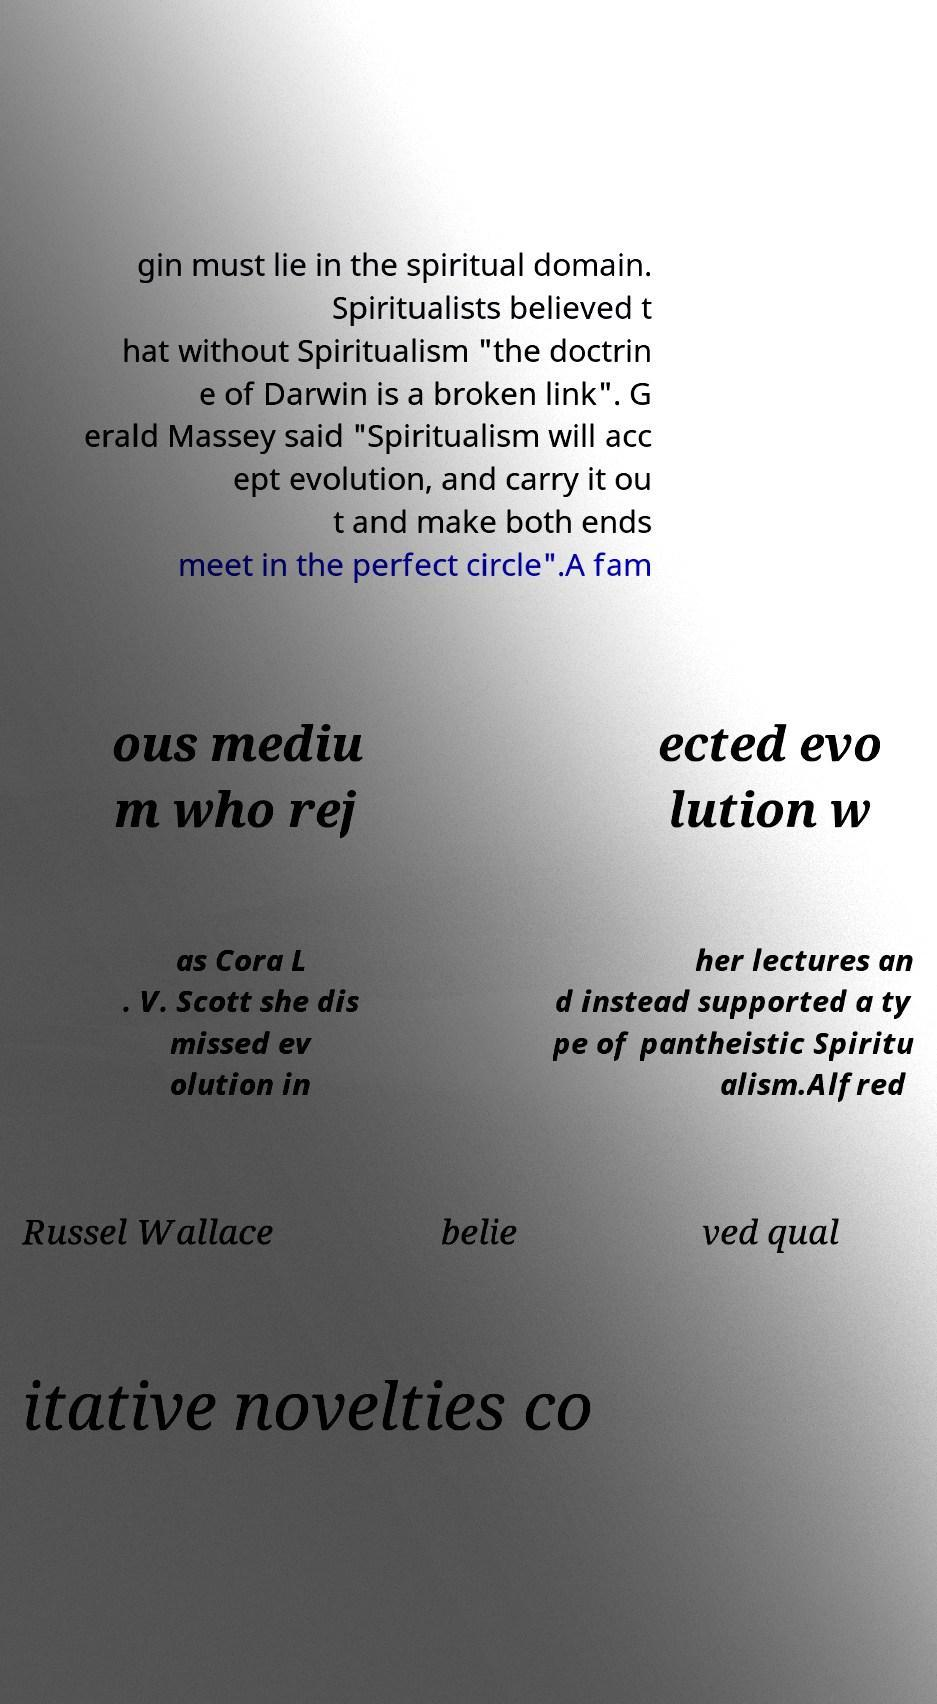Could you assist in decoding the text presented in this image and type it out clearly? gin must lie in the spiritual domain. Spiritualists believed t hat without Spiritualism "the doctrin e of Darwin is a broken link". G erald Massey said "Spiritualism will acc ept evolution, and carry it ou t and make both ends meet in the perfect circle".A fam ous mediu m who rej ected evo lution w as Cora L . V. Scott she dis missed ev olution in her lectures an d instead supported a ty pe of pantheistic Spiritu alism.Alfred Russel Wallace belie ved qual itative novelties co 